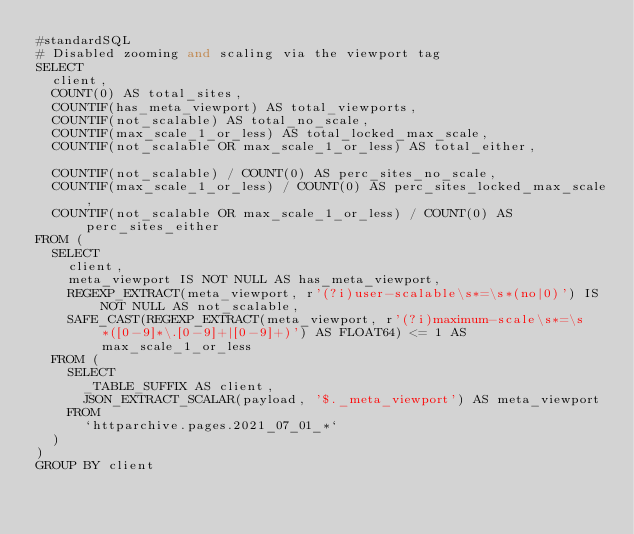Convert code to text. <code><loc_0><loc_0><loc_500><loc_500><_SQL_>#standardSQL
# Disabled zooming and scaling via the viewport tag
SELECT
  client,
  COUNT(0) AS total_sites,
  COUNTIF(has_meta_viewport) AS total_viewports,
  COUNTIF(not_scalable) AS total_no_scale,
  COUNTIF(max_scale_1_or_less) AS total_locked_max_scale,
  COUNTIF(not_scalable OR max_scale_1_or_less) AS total_either,

  COUNTIF(not_scalable) / COUNT(0) AS perc_sites_no_scale,
  COUNTIF(max_scale_1_or_less) / COUNT(0) AS perc_sites_locked_max_scale,
  COUNTIF(not_scalable OR max_scale_1_or_less) / COUNT(0) AS perc_sites_either
FROM (
  SELECT
    client,
    meta_viewport IS NOT NULL AS has_meta_viewport,
    REGEXP_EXTRACT(meta_viewport, r'(?i)user-scalable\s*=\s*(no|0)') IS NOT NULL AS not_scalable,
    SAFE_CAST(REGEXP_EXTRACT(meta_viewport, r'(?i)maximum-scale\s*=\s*([0-9]*\.[0-9]+|[0-9]+)') AS FLOAT64) <= 1 AS max_scale_1_or_less
  FROM (
    SELECT
      _TABLE_SUFFIX AS client,
      JSON_EXTRACT_SCALAR(payload, '$._meta_viewport') AS meta_viewport
    FROM
      `httparchive.pages.2021_07_01_*`
  )
)
GROUP BY client
</code> 